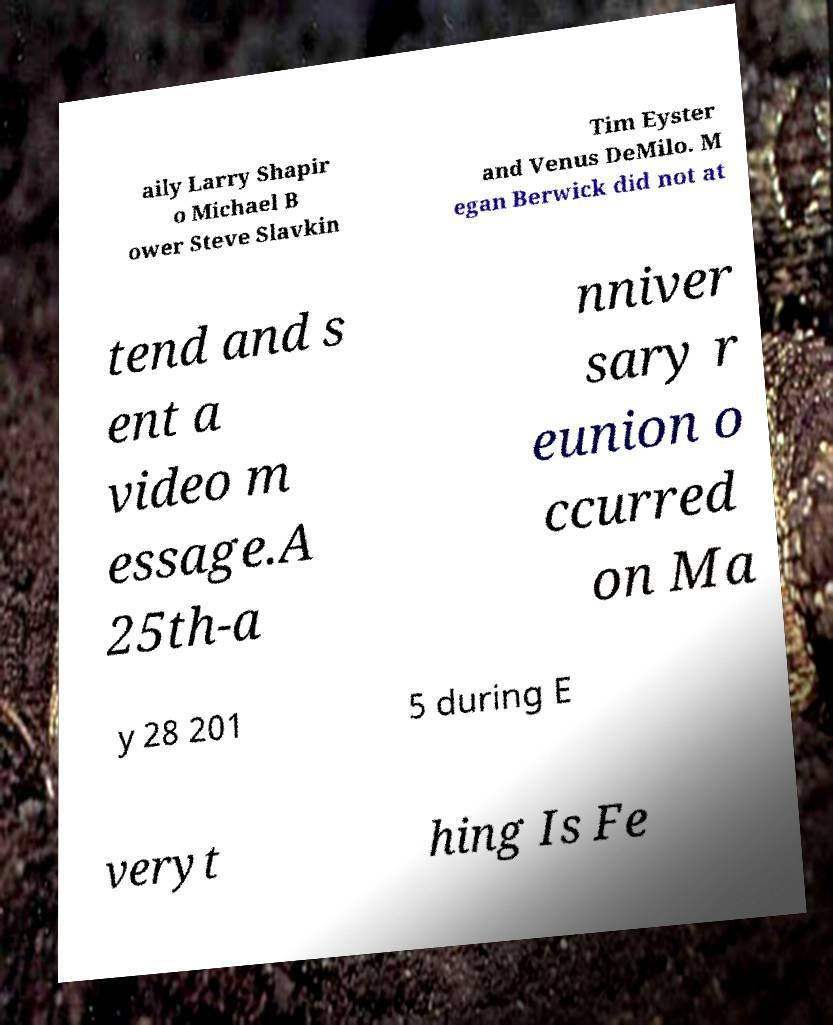Could you extract and type out the text from this image? aily Larry Shapir o Michael B ower Steve Slavkin Tim Eyster and Venus DeMilo. M egan Berwick did not at tend and s ent a video m essage.A 25th-a nniver sary r eunion o ccurred on Ma y 28 201 5 during E veryt hing Is Fe 